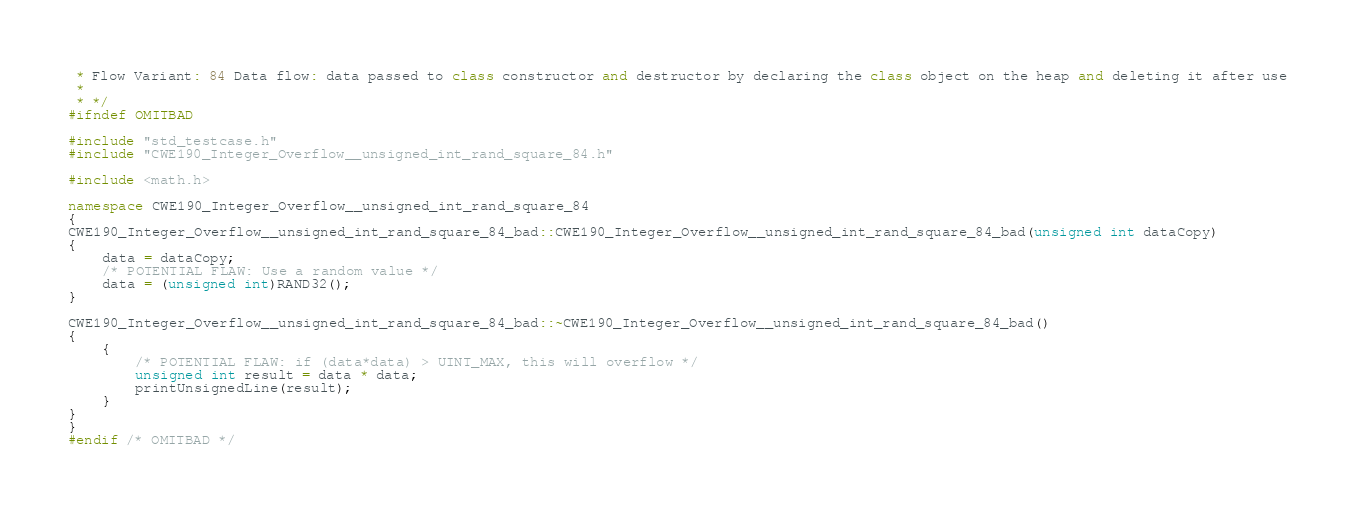Convert code to text. <code><loc_0><loc_0><loc_500><loc_500><_C++_> * Flow Variant: 84 Data flow: data passed to class constructor and destructor by declaring the class object on the heap and deleting it after use
 *
 * */
#ifndef OMITBAD

#include "std_testcase.h"
#include "CWE190_Integer_Overflow__unsigned_int_rand_square_84.h"

#include <math.h>

namespace CWE190_Integer_Overflow__unsigned_int_rand_square_84
{
CWE190_Integer_Overflow__unsigned_int_rand_square_84_bad::CWE190_Integer_Overflow__unsigned_int_rand_square_84_bad(unsigned int dataCopy)
{
    data = dataCopy;
    /* POTENTIAL FLAW: Use a random value */
    data = (unsigned int)RAND32();
}

CWE190_Integer_Overflow__unsigned_int_rand_square_84_bad::~CWE190_Integer_Overflow__unsigned_int_rand_square_84_bad()
{
    {
        /* POTENTIAL FLAW: if (data*data) > UINT_MAX, this will overflow */
        unsigned int result = data * data;
        printUnsignedLine(result);
    }
}
}
#endif /* OMITBAD */
</code> 